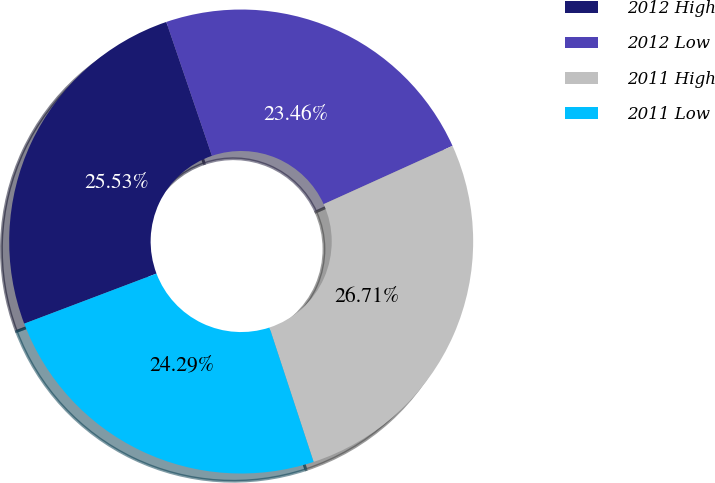Convert chart to OTSL. <chart><loc_0><loc_0><loc_500><loc_500><pie_chart><fcel>2012 High<fcel>2012 Low<fcel>2011 High<fcel>2011 Low<nl><fcel>25.53%<fcel>23.46%<fcel>26.71%<fcel>24.29%<nl></chart> 